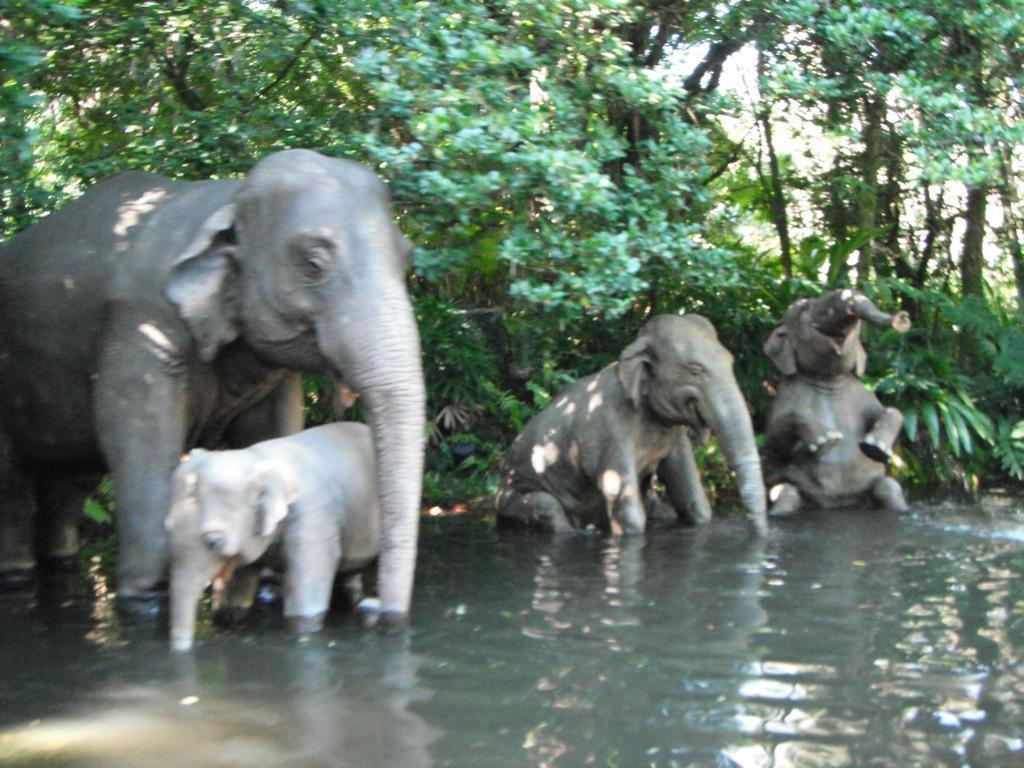In one or two sentences, can you explain what this image depicts? In the image there are few elephants in the pond and behind there are trees. 